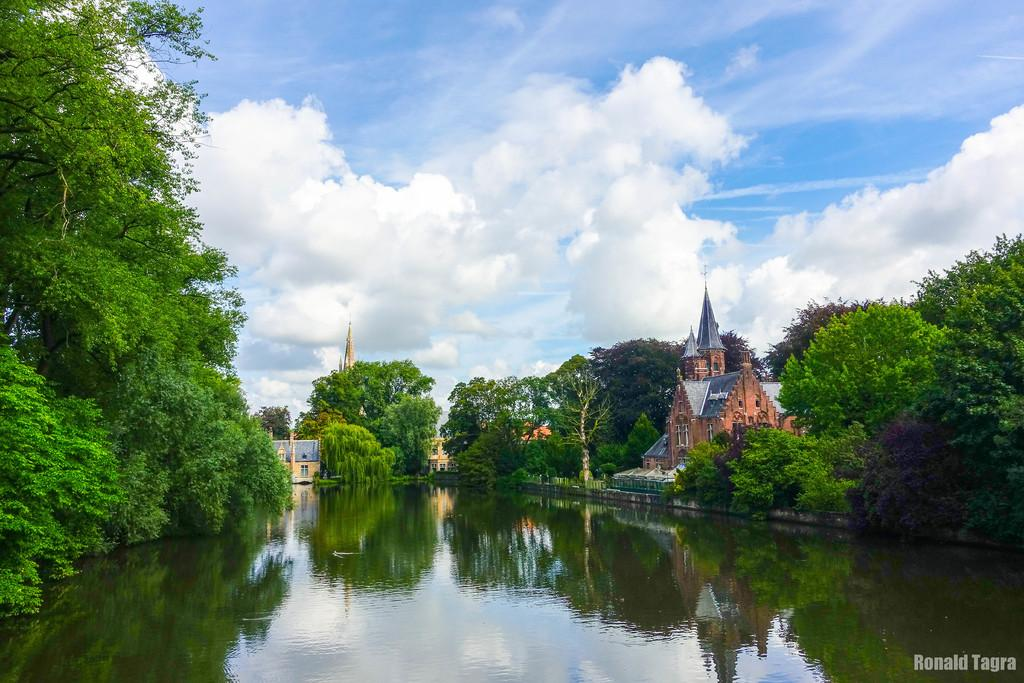What is visible in the image? Water, trees, houses, and clouds are present in the image. Can you describe the natural elements in the image? There are trees and water visible in the image. What type of structures can be seen in the image? Houses are present in the image. What is visible in the sky in the image? Clouds are present in the image. What type of class is being held in the image? There is no class present in the image; it features water, trees, houses, and clouds. What type of work is being done in the image? There is no work being done in the image; it features water, trees, houses, and clouds. 